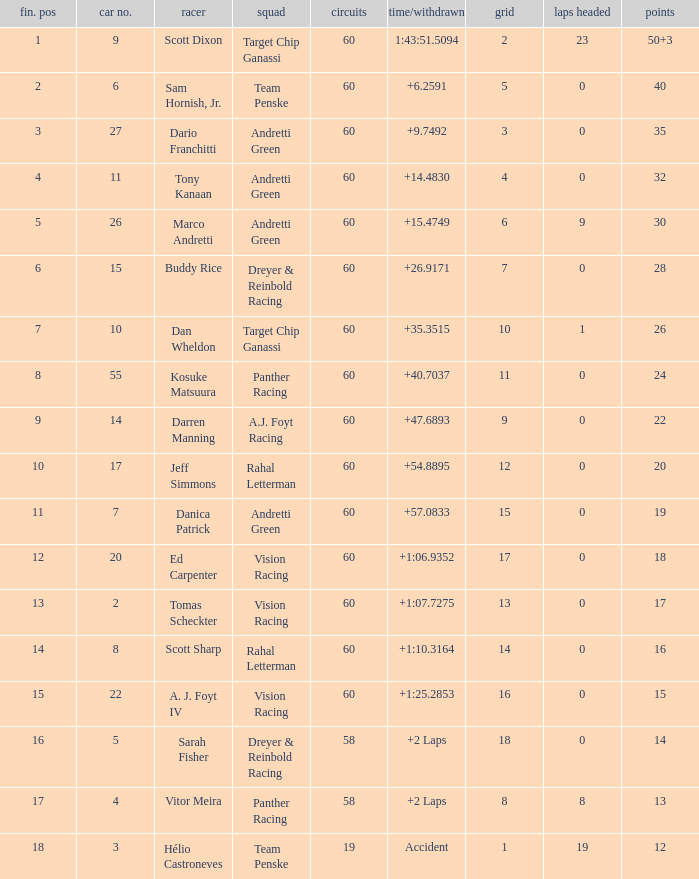Name the laps for 18 pointss 60.0. 